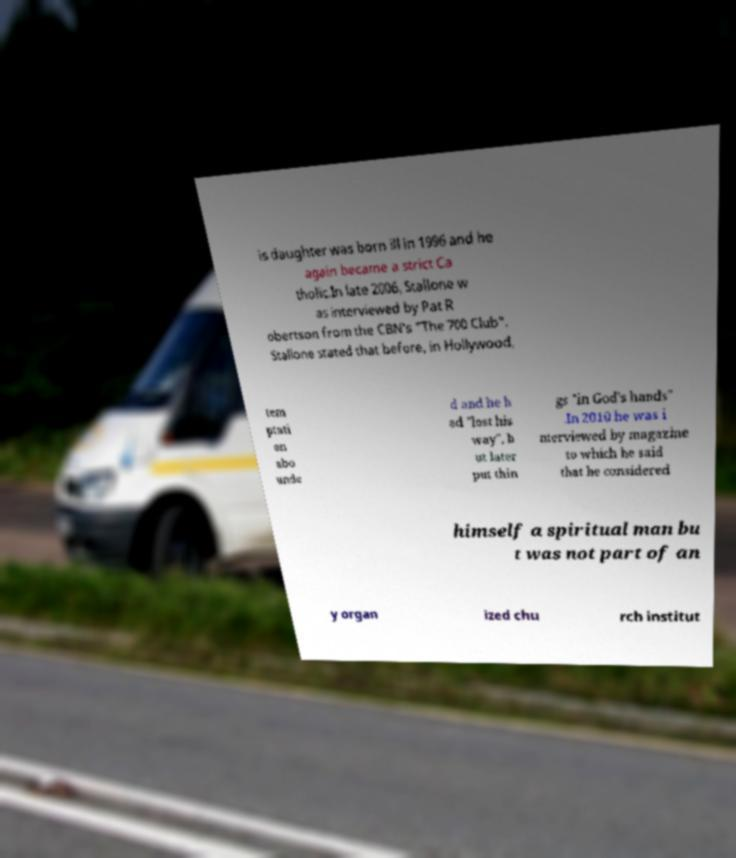Could you extract and type out the text from this image? is daughter was born ill in 1996 and he again became a strict Ca tholic.In late 2006, Stallone w as interviewed by Pat R obertson from the CBN's "The 700 Club". Stallone stated that before, in Hollywood, tem ptati on abo unde d and he h ad "lost his way", b ut later put thin gs "in God's hands" .In 2010 he was i nterviewed by magazine to which he said that he considered himself a spiritual man bu t was not part of an y organ ized chu rch institut 